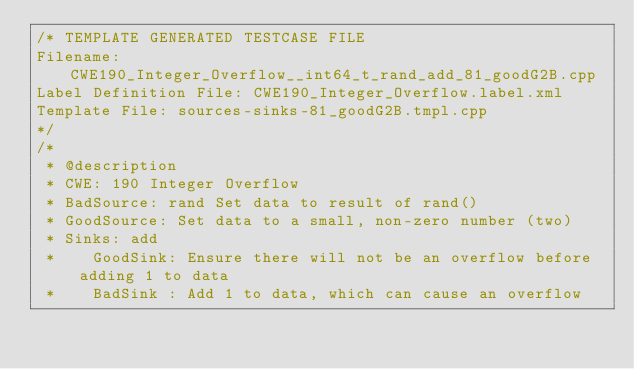<code> <loc_0><loc_0><loc_500><loc_500><_C++_>/* TEMPLATE GENERATED TESTCASE FILE
Filename: CWE190_Integer_Overflow__int64_t_rand_add_81_goodG2B.cpp
Label Definition File: CWE190_Integer_Overflow.label.xml
Template File: sources-sinks-81_goodG2B.tmpl.cpp
*/
/*
 * @description
 * CWE: 190 Integer Overflow
 * BadSource: rand Set data to result of rand()
 * GoodSource: Set data to a small, non-zero number (two)
 * Sinks: add
 *    GoodSink: Ensure there will not be an overflow before adding 1 to data
 *    BadSink : Add 1 to data, which can cause an overflow</code> 